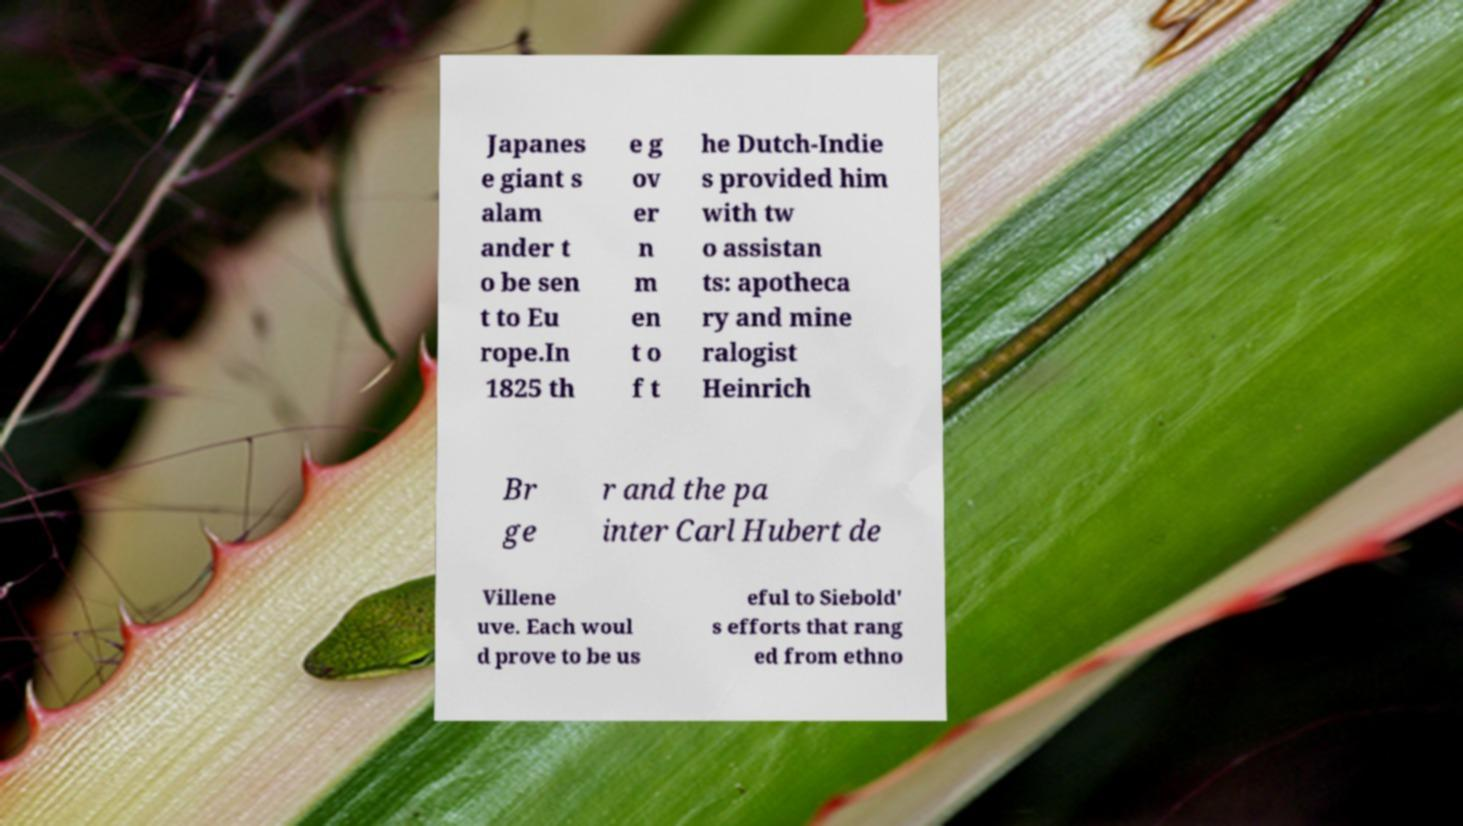I need the written content from this picture converted into text. Can you do that? Japanes e giant s alam ander t o be sen t to Eu rope.In 1825 th e g ov er n m en t o f t he Dutch-Indie s provided him with tw o assistan ts: apotheca ry and mine ralogist Heinrich Br ge r and the pa inter Carl Hubert de Villene uve. Each woul d prove to be us eful to Siebold' s efforts that rang ed from ethno 